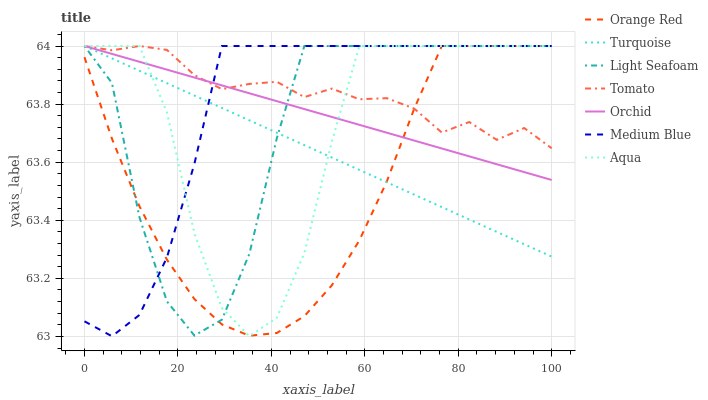Does Orange Red have the minimum area under the curve?
Answer yes or no. Yes. Does Tomato have the maximum area under the curve?
Answer yes or no. Yes. Does Turquoise have the minimum area under the curve?
Answer yes or no. No. Does Turquoise have the maximum area under the curve?
Answer yes or no. No. Is Turquoise the smoothest?
Answer yes or no. Yes. Is Aqua the roughest?
Answer yes or no. Yes. Is Aqua the smoothest?
Answer yes or no. No. Is Turquoise the roughest?
Answer yes or no. No. Does Turquoise have the lowest value?
Answer yes or no. No. 